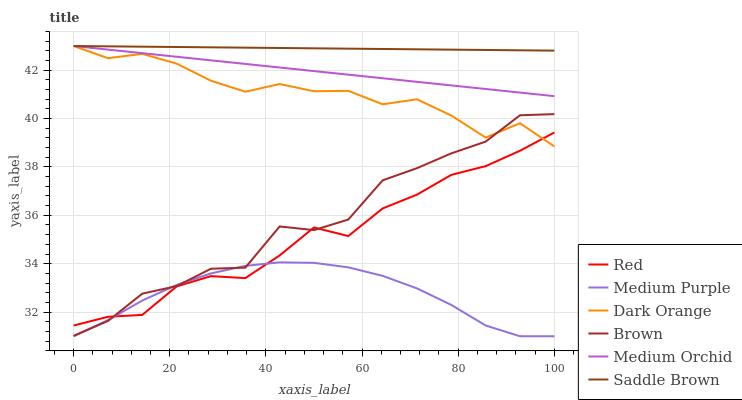Does Medium Purple have the minimum area under the curve?
Answer yes or no. Yes. Does Saddle Brown have the maximum area under the curve?
Answer yes or no. Yes. Does Brown have the minimum area under the curve?
Answer yes or no. No. Does Brown have the maximum area under the curve?
Answer yes or no. No. Is Saddle Brown the smoothest?
Answer yes or no. Yes. Is Brown the roughest?
Answer yes or no. Yes. Is Medium Orchid the smoothest?
Answer yes or no. No. Is Medium Orchid the roughest?
Answer yes or no. No. Does Brown have the lowest value?
Answer yes or no. No. Does Brown have the highest value?
Answer yes or no. No. Is Medium Purple less than Medium Orchid?
Answer yes or no. Yes. Is Saddle Brown greater than Red?
Answer yes or no. Yes. Does Medium Purple intersect Medium Orchid?
Answer yes or no. No. 